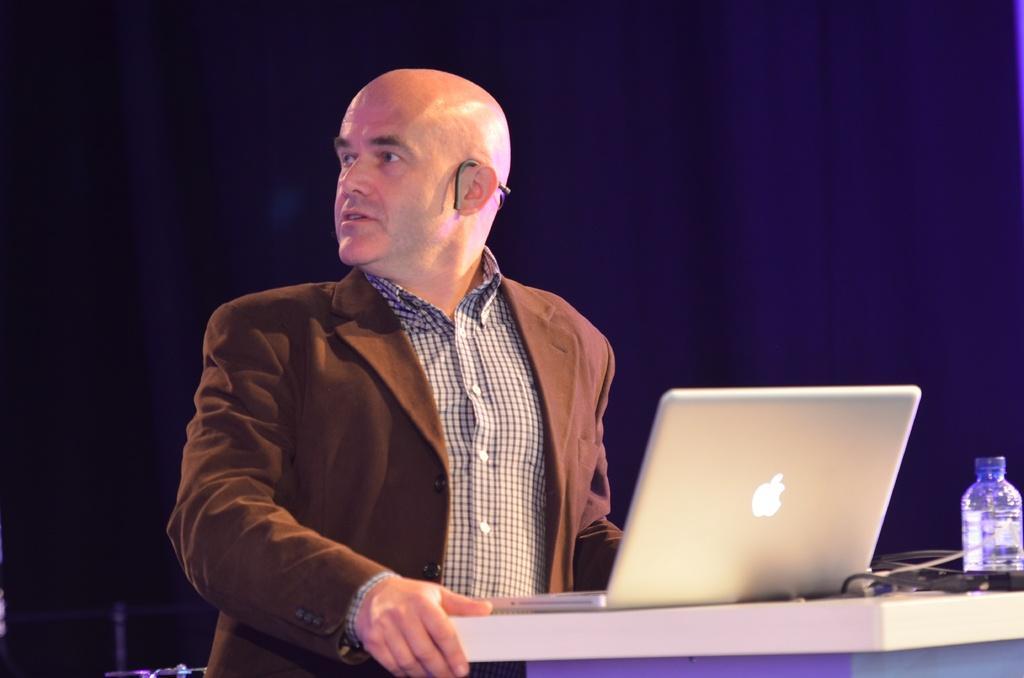Please provide a concise description of this image. In this picture we can see a man in front of him we can find a laptop and bottle on the table. 